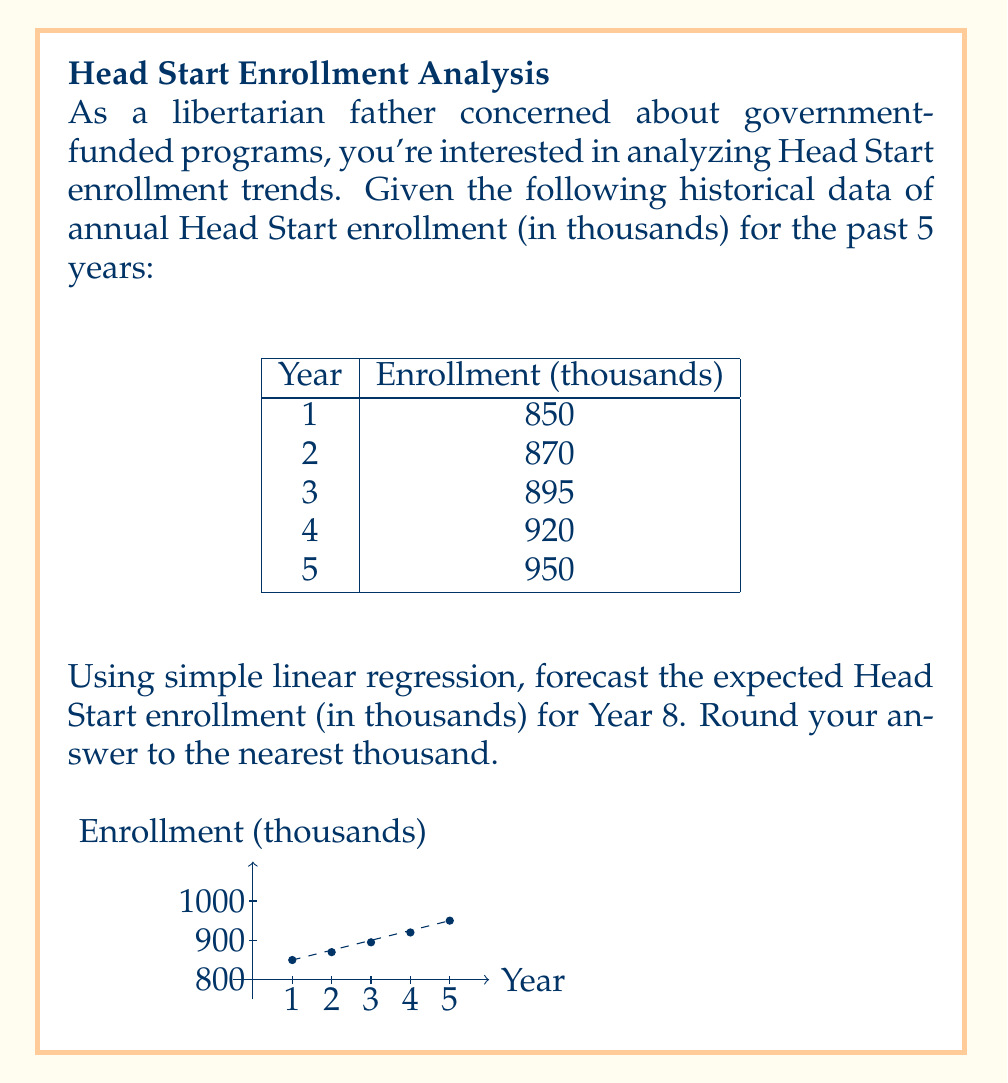Show me your answer to this math problem. To solve this problem using simple linear regression, we'll follow these steps:

1) First, let's set up our data:
   x (years): 1, 2, 3, 4, 5
   y (enrollment in thousands): 850, 870, 895, 920, 950

2) We need to calculate the following:
   $n = 5$ (number of data points)
   $\sum x = 1 + 2 + 3 + 4 + 5 = 15$
   $\sum y = 850 + 870 + 895 + 920 + 950 = 4485$
   $\sum x^2 = 1^2 + 2^2 + 3^2 + 4^2 + 5^2 = 55$
   $\sum xy = 1(850) + 2(870) + 3(895) + 4(920) + 5(950) = 13,590$

3) Now we can calculate the slope (m) and y-intercept (b) of our regression line:

   $m = \frac{n\sum xy - \sum x \sum y}{n\sum x^2 - (\sum x)^2}$
   $m = \frac{5(13,590) - 15(4485)}{5(55) - 15^2} = \frac{67,950 - 67,275}{275 - 225} = \frac{675}{50} = 13.5$

   $b = \frac{\sum y - m\sum x}{n}$
   $b = \frac{4485 - 13.5(15)}{5} = \frac{4485 - 202.5}{5} = 856.5$

4) Our regression line equation is:
   $y = 13.5x + 856.5$

5) To forecast Year 8, we substitute x = 8:
   $y = 13.5(8) + 856.5 = 108 + 856.5 = 964.5$

6) Rounding to the nearest thousand:
   964.5 thousand ≈ 965 thousand
Answer: 965 thousand 